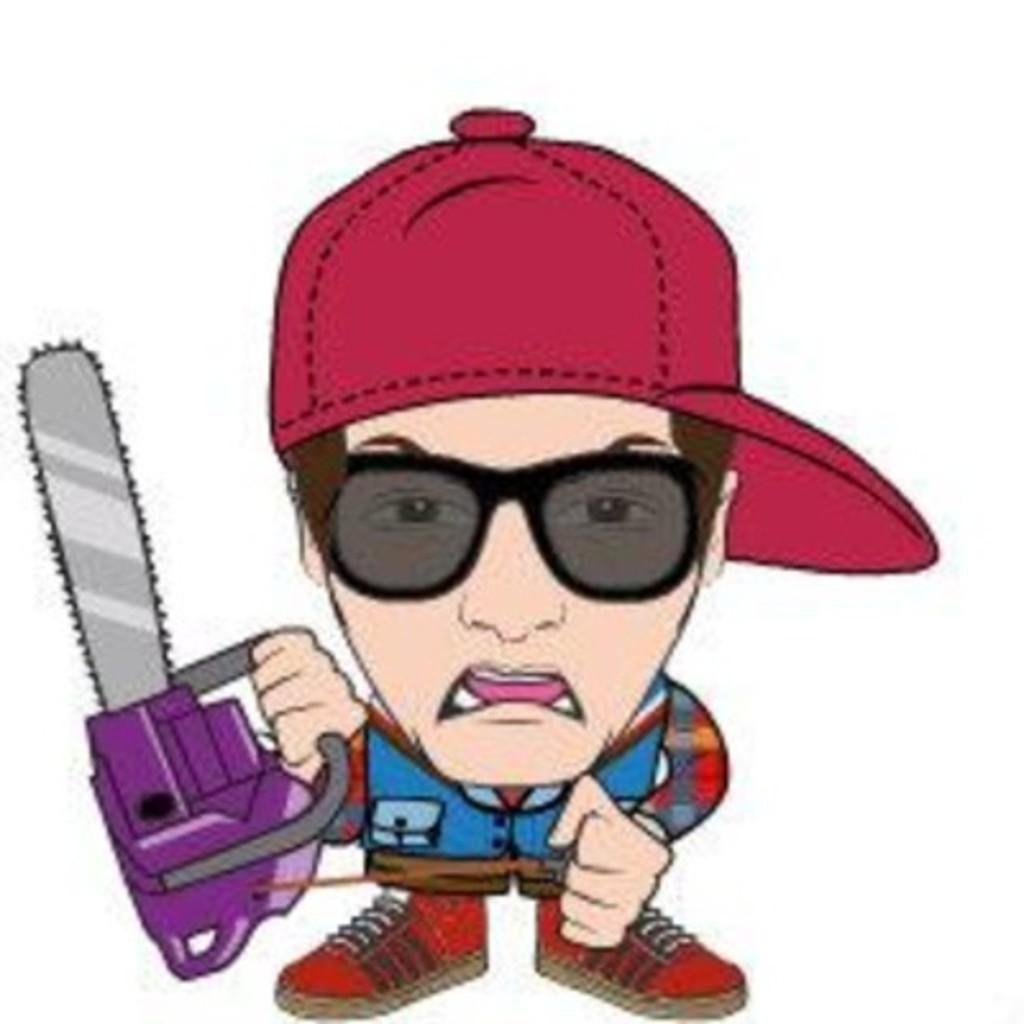In one or two sentences, can you explain what this image depicts? This image is an animated image. In the middle there is a man, he wears a shirt, shoe, cap, he is holding a machine. 